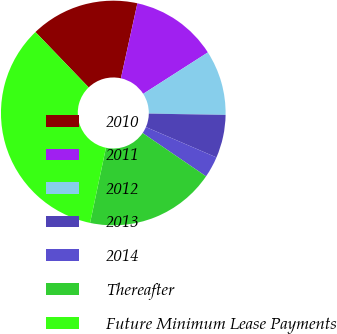Convert chart to OTSL. <chart><loc_0><loc_0><loc_500><loc_500><pie_chart><fcel>2010<fcel>2011<fcel>2012<fcel>2013<fcel>2014<fcel>Thereafter<fcel>Future Minimum Lease Payments<nl><fcel>15.63%<fcel>12.49%<fcel>9.34%<fcel>6.2%<fcel>3.06%<fcel>18.78%<fcel>34.5%<nl></chart> 